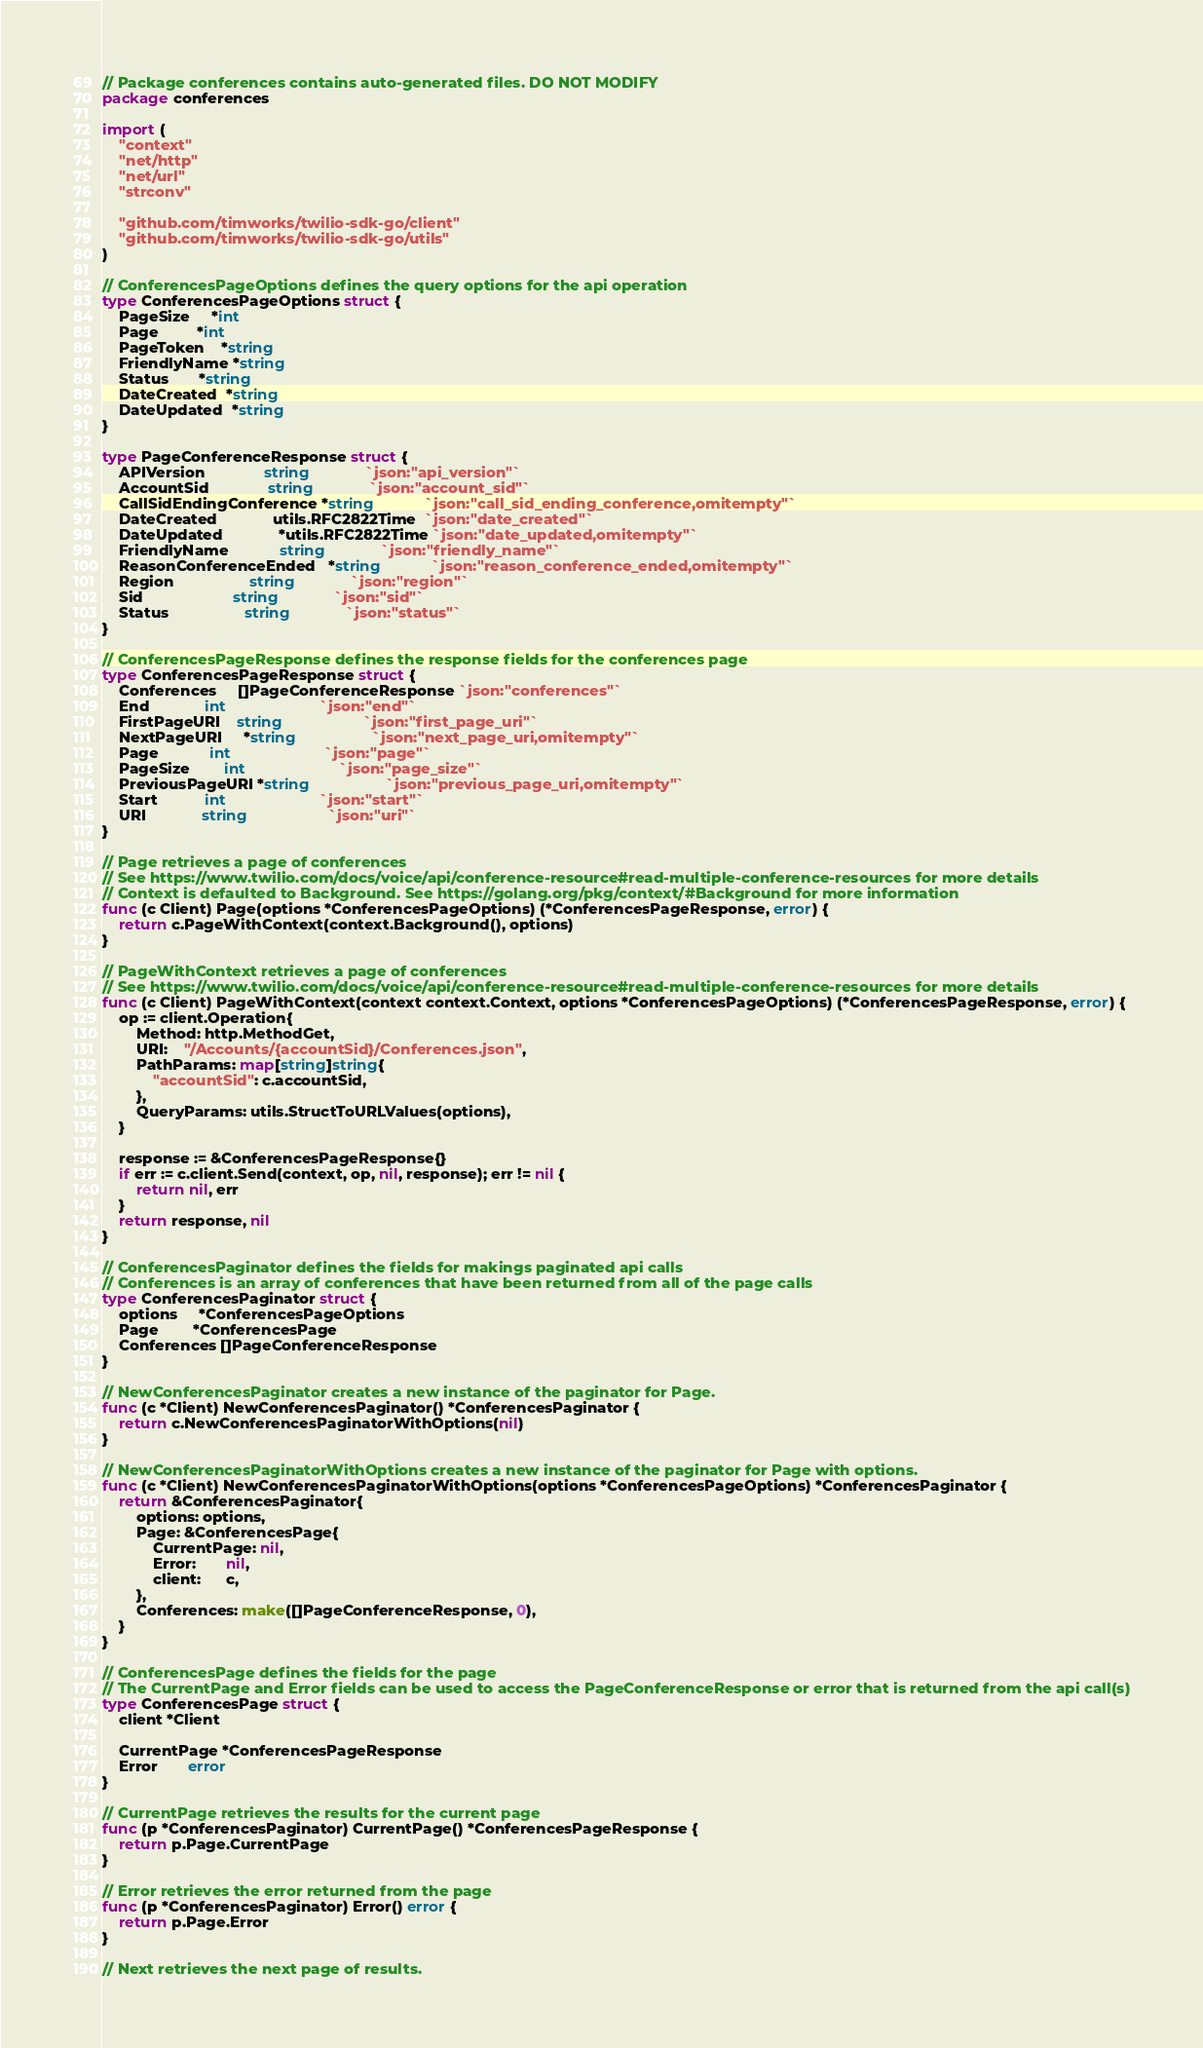<code> <loc_0><loc_0><loc_500><loc_500><_Go_>// Package conferences contains auto-generated files. DO NOT MODIFY
package conferences

import (
	"context"
	"net/http"
	"net/url"
	"strconv"

	"github.com/timworks/twilio-sdk-go/client"
	"github.com/timworks/twilio-sdk-go/utils"
)

// ConferencesPageOptions defines the query options for the api operation
type ConferencesPageOptions struct {
	PageSize     *int
	Page         *int
	PageToken    *string
	FriendlyName *string
	Status       *string
	DateCreated  *string
	DateUpdated  *string
}

type PageConferenceResponse struct {
	APIVersion              string             `json:"api_version"`
	AccountSid              string             `json:"account_sid"`
	CallSidEndingConference *string            `json:"call_sid_ending_conference,omitempty"`
	DateCreated             utils.RFC2822Time  `json:"date_created"`
	DateUpdated             *utils.RFC2822Time `json:"date_updated,omitempty"`
	FriendlyName            string             `json:"friendly_name"`
	ReasonConferenceEnded   *string            `json:"reason_conference_ended,omitempty"`
	Region                  string             `json:"region"`
	Sid                     string             `json:"sid"`
	Status                  string             `json:"status"`
}

// ConferencesPageResponse defines the response fields for the conferences page
type ConferencesPageResponse struct {
	Conferences     []PageConferenceResponse `json:"conferences"`
	End             int                      `json:"end"`
	FirstPageURI    string                   `json:"first_page_uri"`
	NextPageURI     *string                  `json:"next_page_uri,omitempty"`
	Page            int                      `json:"page"`
	PageSize        int                      `json:"page_size"`
	PreviousPageURI *string                  `json:"previous_page_uri,omitempty"`
	Start           int                      `json:"start"`
	URI             string                   `json:"uri"`
}

// Page retrieves a page of conferences
// See https://www.twilio.com/docs/voice/api/conference-resource#read-multiple-conference-resources for more details
// Context is defaulted to Background. See https://golang.org/pkg/context/#Background for more information
func (c Client) Page(options *ConferencesPageOptions) (*ConferencesPageResponse, error) {
	return c.PageWithContext(context.Background(), options)
}

// PageWithContext retrieves a page of conferences
// See https://www.twilio.com/docs/voice/api/conference-resource#read-multiple-conference-resources for more details
func (c Client) PageWithContext(context context.Context, options *ConferencesPageOptions) (*ConferencesPageResponse, error) {
	op := client.Operation{
		Method: http.MethodGet,
		URI:    "/Accounts/{accountSid}/Conferences.json",
		PathParams: map[string]string{
			"accountSid": c.accountSid,
		},
		QueryParams: utils.StructToURLValues(options),
	}

	response := &ConferencesPageResponse{}
	if err := c.client.Send(context, op, nil, response); err != nil {
		return nil, err
	}
	return response, nil
}

// ConferencesPaginator defines the fields for makings paginated api calls
// Conferences is an array of conferences that have been returned from all of the page calls
type ConferencesPaginator struct {
	options     *ConferencesPageOptions
	Page        *ConferencesPage
	Conferences []PageConferenceResponse
}

// NewConferencesPaginator creates a new instance of the paginator for Page.
func (c *Client) NewConferencesPaginator() *ConferencesPaginator {
	return c.NewConferencesPaginatorWithOptions(nil)
}

// NewConferencesPaginatorWithOptions creates a new instance of the paginator for Page with options.
func (c *Client) NewConferencesPaginatorWithOptions(options *ConferencesPageOptions) *ConferencesPaginator {
	return &ConferencesPaginator{
		options: options,
		Page: &ConferencesPage{
			CurrentPage: nil,
			Error:       nil,
			client:      c,
		},
		Conferences: make([]PageConferenceResponse, 0),
	}
}

// ConferencesPage defines the fields for the page
// The CurrentPage and Error fields can be used to access the PageConferenceResponse or error that is returned from the api call(s)
type ConferencesPage struct {
	client *Client

	CurrentPage *ConferencesPageResponse
	Error       error
}

// CurrentPage retrieves the results for the current page
func (p *ConferencesPaginator) CurrentPage() *ConferencesPageResponse {
	return p.Page.CurrentPage
}

// Error retrieves the error returned from the page
func (p *ConferencesPaginator) Error() error {
	return p.Page.Error
}

// Next retrieves the next page of results.</code> 